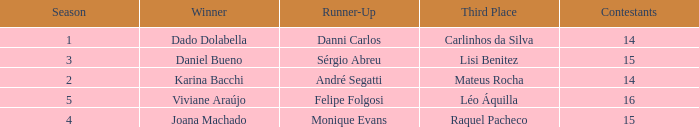In what season was the winner Dado Dolabella? 1.0. 